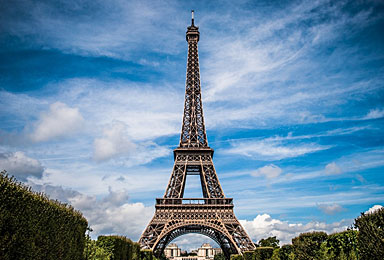راجع به تصویر زیر توضیح بده
 This image depicts the iconic Eiffel Tower in Paris, France. The tower stands tall against a beautiful blue sky with fluffy white clouds. The latticed wrought-iron structure of the Eiffel Tower is clearly visible, soaring to a great height. The famous Parisian monument appears to have been captured on a pleasant day, with trees or foliage visible in the foreground. The Eiffel Tower is one of the most recognizable landmarks in the world and a beloved symbol of the city of Paris, drawing millions of visitors each year to marvel at its architectural grandeur and significance as a historic cultural attraction. 